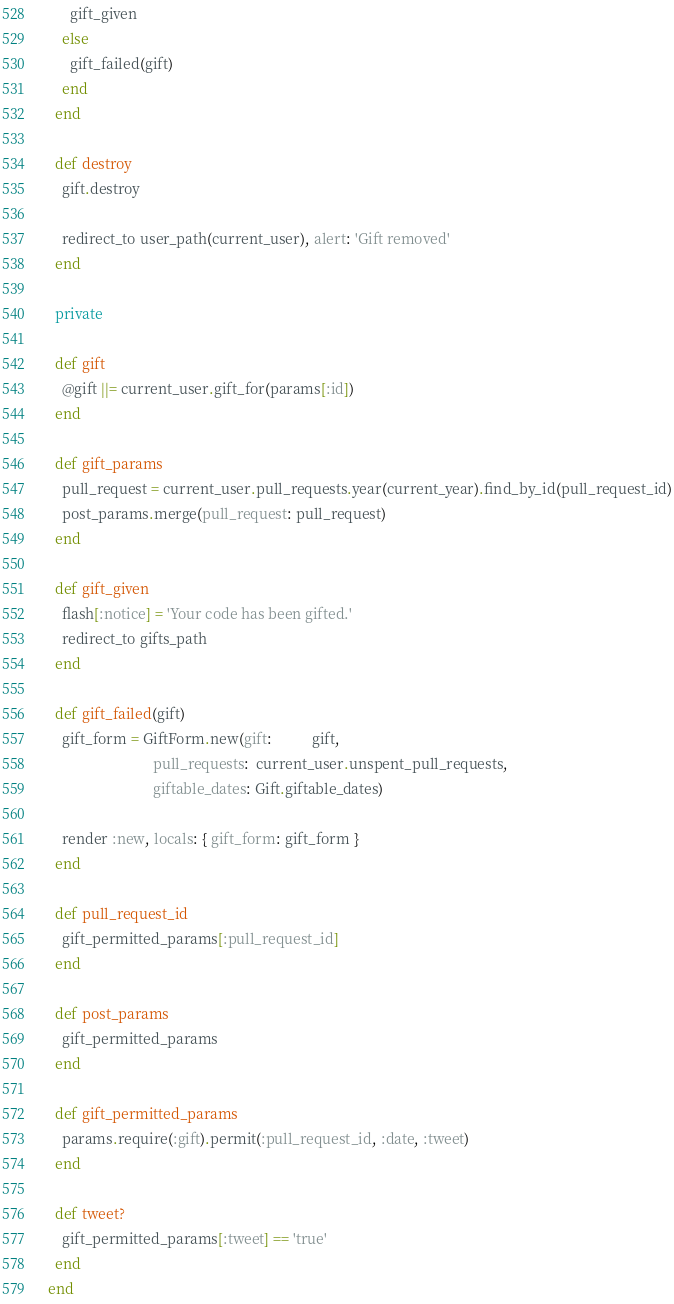<code> <loc_0><loc_0><loc_500><loc_500><_Ruby_>      gift_given
    else
      gift_failed(gift)
    end
  end

  def destroy
    gift.destroy

    redirect_to user_path(current_user), alert: 'Gift removed'
  end

  private

  def gift
    @gift ||= current_user.gift_for(params[:id])
  end

  def gift_params
    pull_request = current_user.pull_requests.year(current_year).find_by_id(pull_request_id)
    post_params.merge(pull_request: pull_request)
  end

  def gift_given
    flash[:notice] = 'Your code has been gifted.'
    redirect_to gifts_path
  end

  def gift_failed(gift)
    gift_form = GiftForm.new(gift:           gift,
                             pull_requests:  current_user.unspent_pull_requests,
                             giftable_dates: Gift.giftable_dates)

    render :new, locals: { gift_form: gift_form }
  end

  def pull_request_id
    gift_permitted_params[:pull_request_id]
  end

  def post_params
    gift_permitted_params
  end

  def gift_permitted_params
    params.require(:gift).permit(:pull_request_id, :date, :tweet)
  end

  def tweet?
    gift_permitted_params[:tweet] == 'true'
  end
end
</code> 